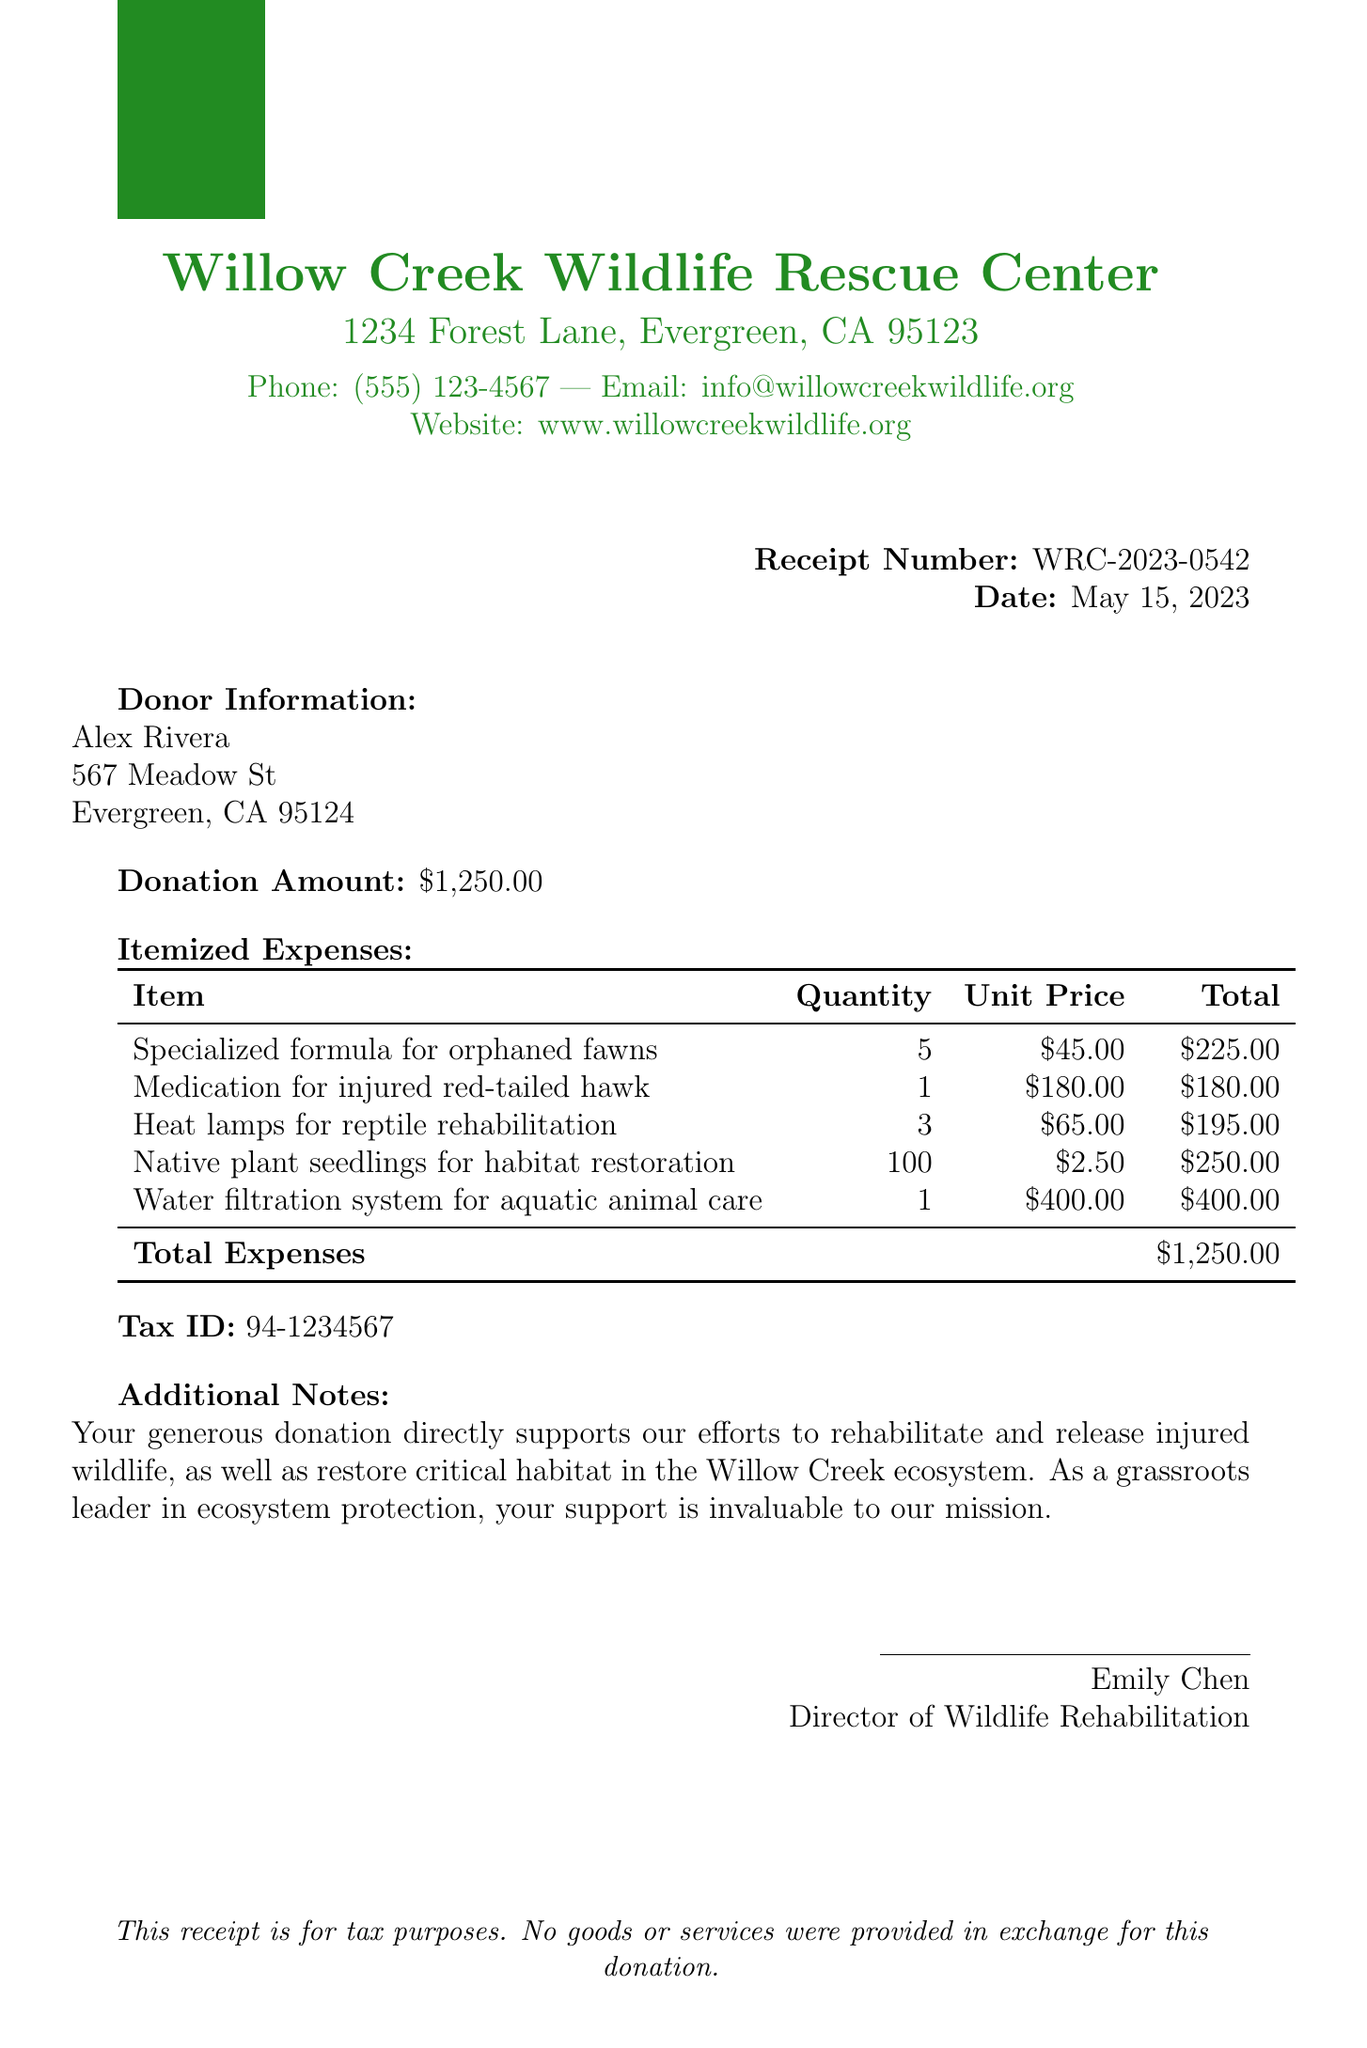What is the receipt number? The receipt number is listed prominently at the top of the document.
Answer: WRC-2023-0542 Who is the donor? The donor's name is mentioned in the donor information section.
Answer: Alex Rivera What is the donation amount? The total donation amount is stated clearly in the document.
Answer: $1,250.00 How many units of specialized formula were purchased? The quantity for specialized formula is specified in the itemized expenses section.
Answer: 5 What is the total for the water filtration system? The total for each item is provided, and it can be found in the itemized expenses.
Answer: $400.00 What is the tax ID of the organization? The tax ID is included in the document as a separate line item.
Answer: 94-1234567 What is the purpose of the donation according to the additional notes? The additional notes section describes the purpose of the donation.
Answer: rehabilitate and release injured wildlife Who signed the receipt? The signature section contains the name of the individual who signed the document.
Answer: Emily Chen How many native plant seedlings were purchased? The quantity of native plant seedlings is itemized in the expenses.
Answer: 100 